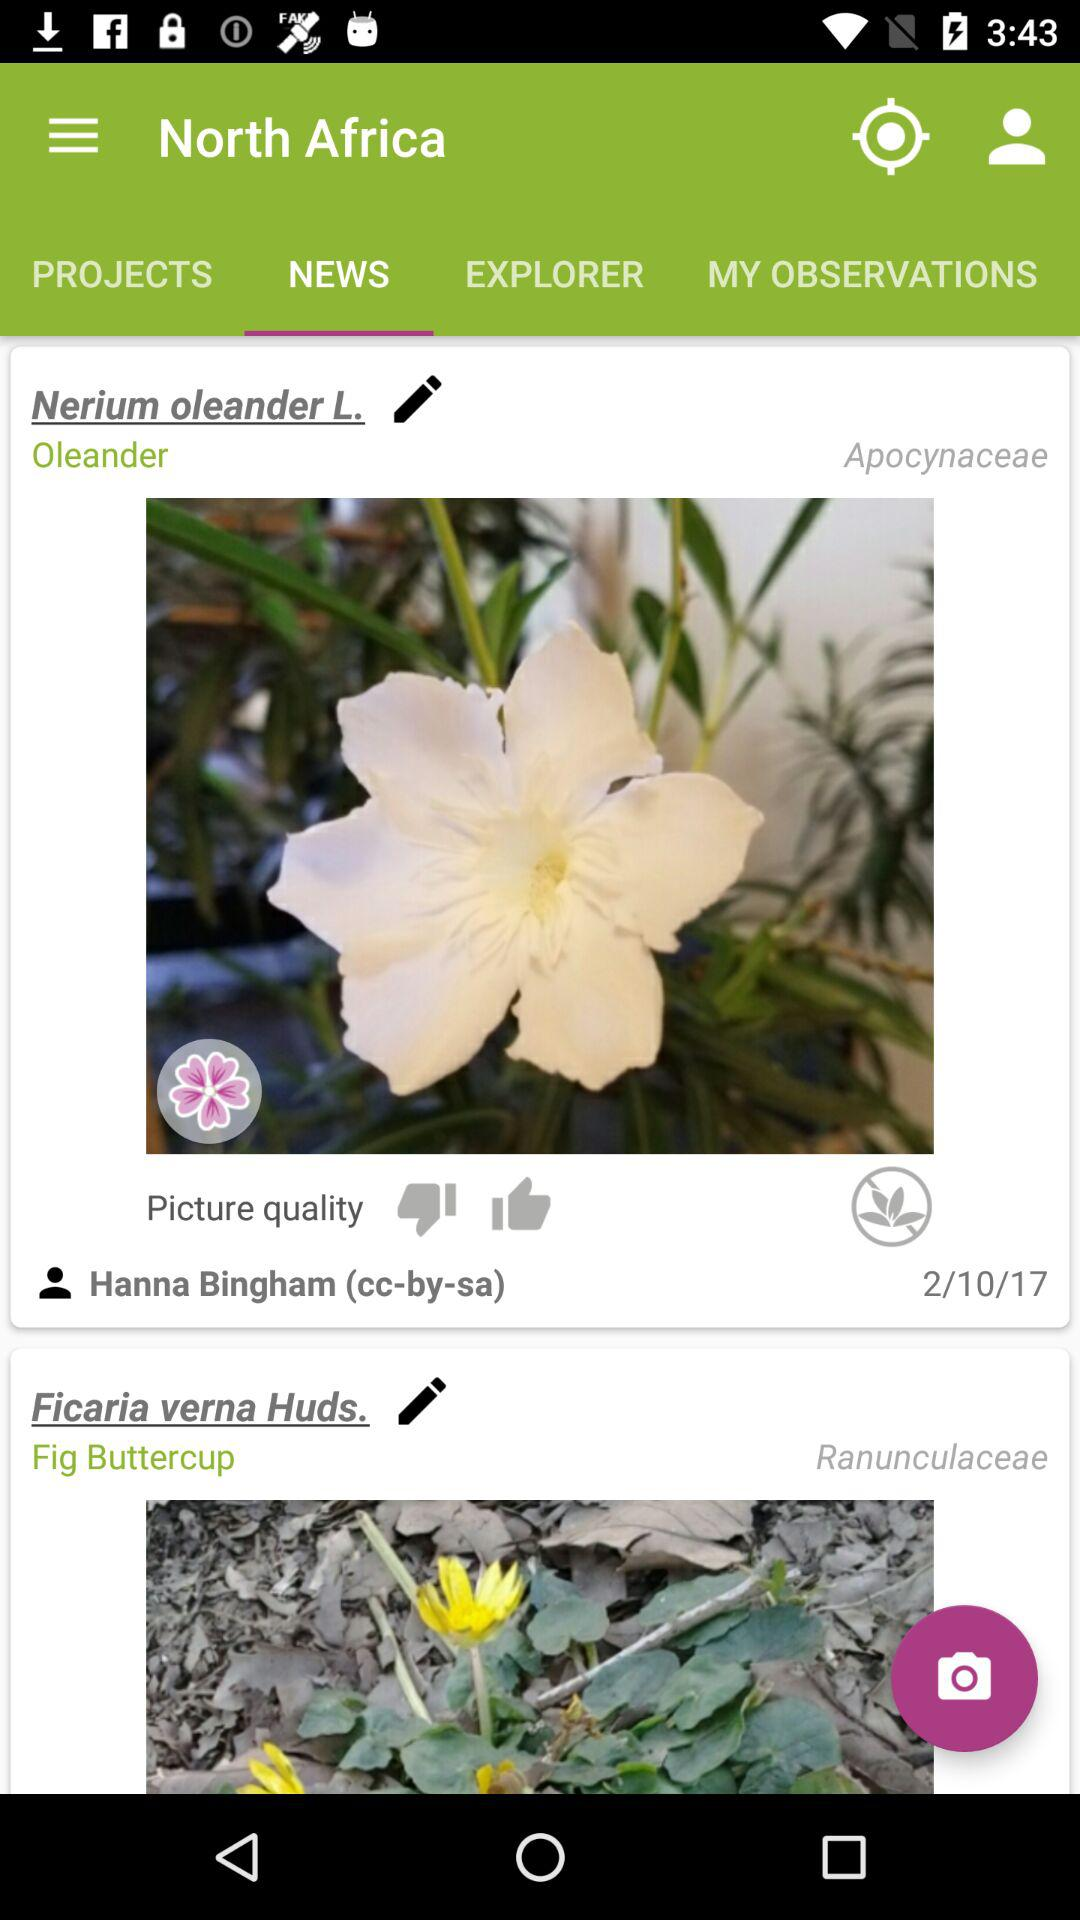What is the scientific name of the fig buttercup? The scientific name of the fig buttercup is "Ficaria verna". 